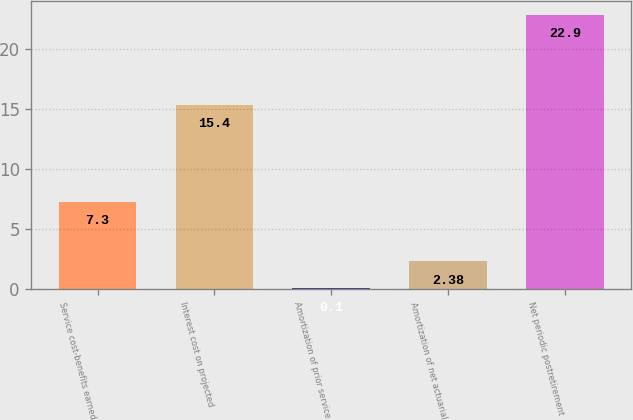<chart> <loc_0><loc_0><loc_500><loc_500><bar_chart><fcel>Service cost-benefits earned<fcel>Interest cost on projected<fcel>Amortization of prior service<fcel>Amortization of net actuarial<fcel>Net periodic postretirement<nl><fcel>7.3<fcel>15.4<fcel>0.1<fcel>2.38<fcel>22.9<nl></chart> 